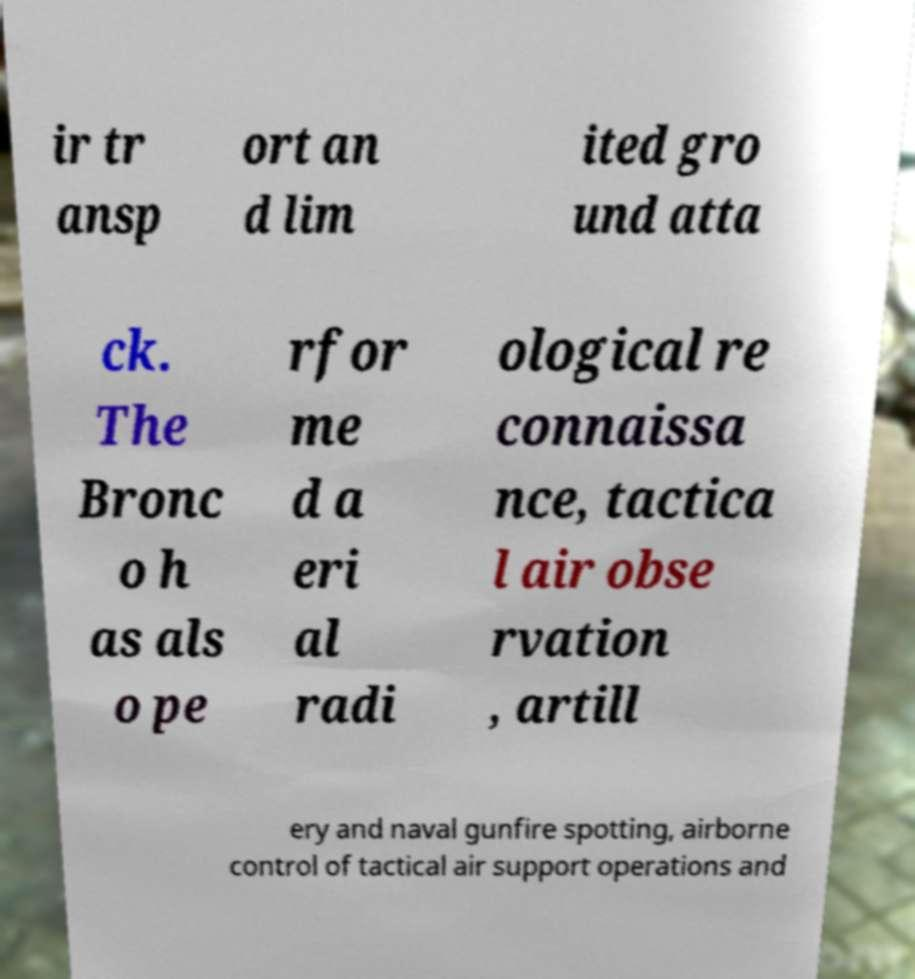What messages or text are displayed in this image? I need them in a readable, typed format. ir tr ansp ort an d lim ited gro und atta ck. The Bronc o h as als o pe rfor me d a eri al radi ological re connaissa nce, tactica l air obse rvation , artill ery and naval gunfire spotting, airborne control of tactical air support operations and 